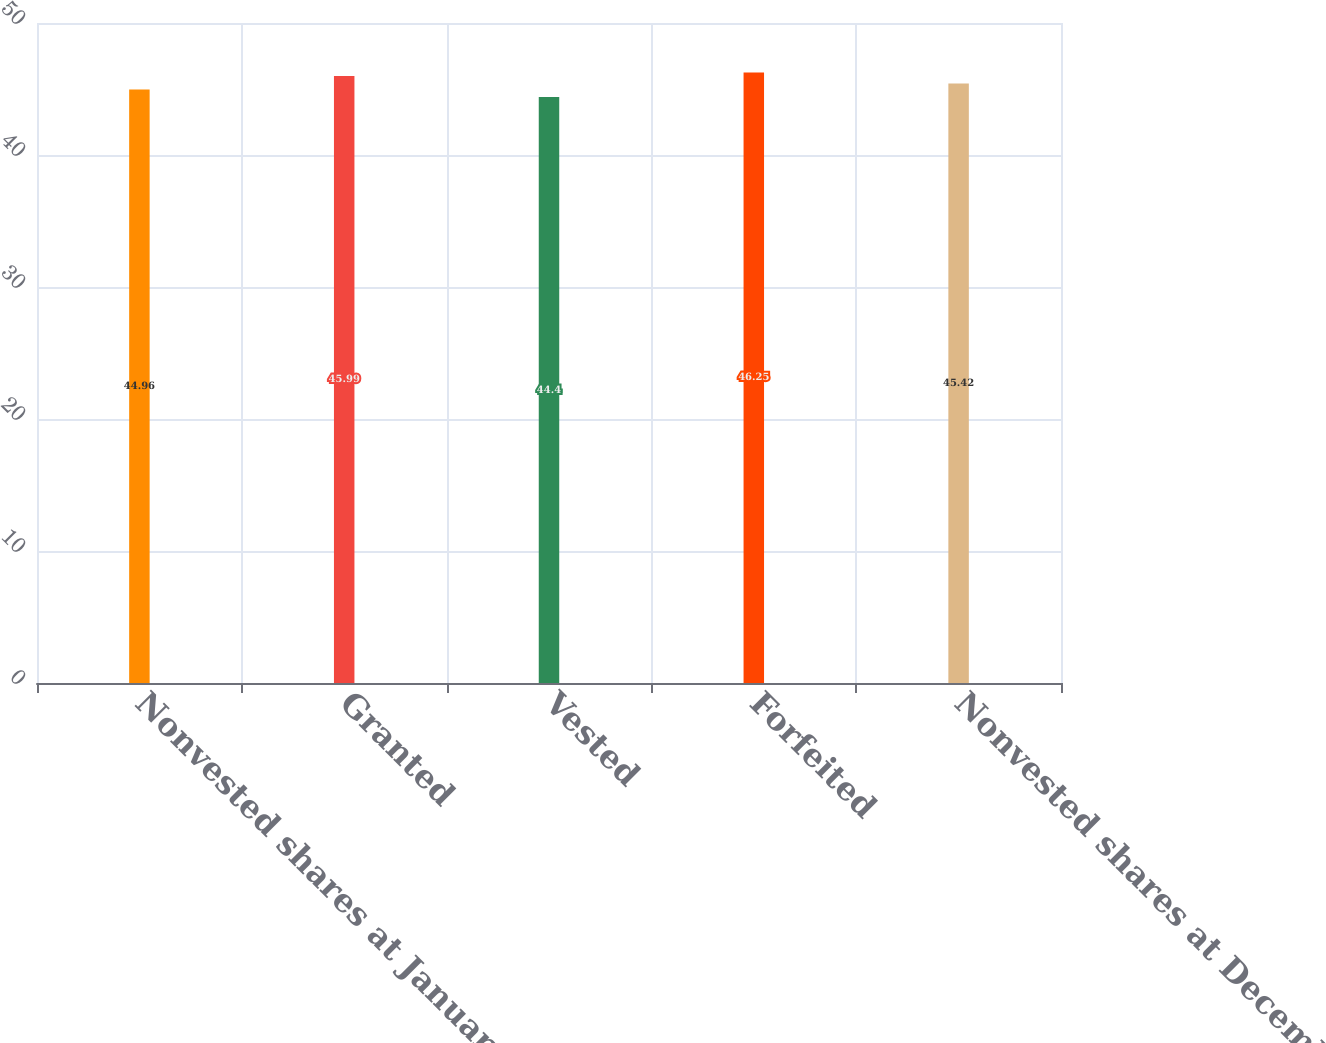Convert chart to OTSL. <chart><loc_0><loc_0><loc_500><loc_500><bar_chart><fcel>Nonvested shares at January 1<fcel>Granted<fcel>Vested<fcel>Forfeited<fcel>Nonvested shares at December<nl><fcel>44.96<fcel>45.99<fcel>44.4<fcel>46.25<fcel>45.42<nl></chart> 